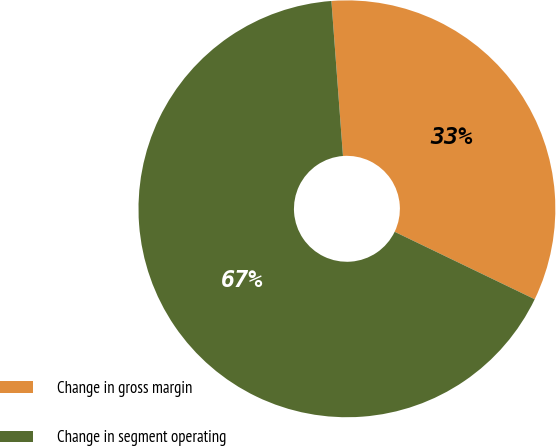<chart> <loc_0><loc_0><loc_500><loc_500><pie_chart><fcel>Change in gross margin<fcel>Change in segment operating<nl><fcel>33.33%<fcel>66.67%<nl></chart> 